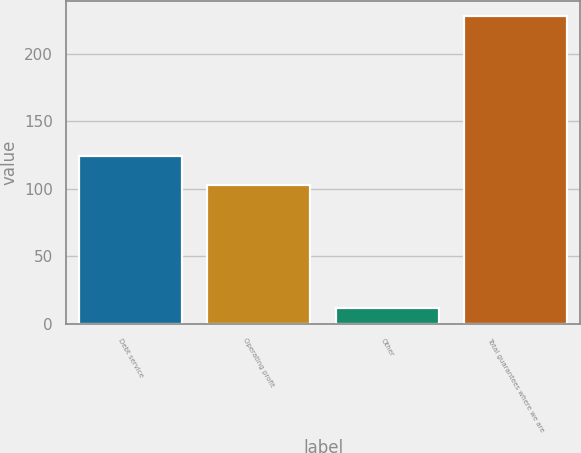Convert chart. <chart><loc_0><loc_0><loc_500><loc_500><bar_chart><fcel>Debt service<fcel>Operating profit<fcel>Other<fcel>Total guarantees where we are<nl><fcel>124.6<fcel>103<fcel>12<fcel>228<nl></chart> 